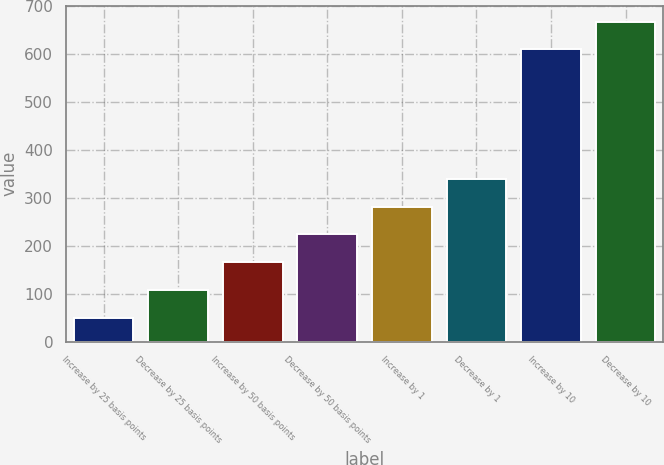Convert chart. <chart><loc_0><loc_0><loc_500><loc_500><bar_chart><fcel>Increase by 25 basis points<fcel>Decrease by 25 basis points<fcel>Increase by 50 basis points<fcel>Decrease by 50 basis points<fcel>Increase by 1<fcel>Decrease by 1<fcel>Increase by 10<fcel>Decrease by 10<nl><fcel>50<fcel>108<fcel>166<fcel>224<fcel>282<fcel>340<fcel>610<fcel>668<nl></chart> 